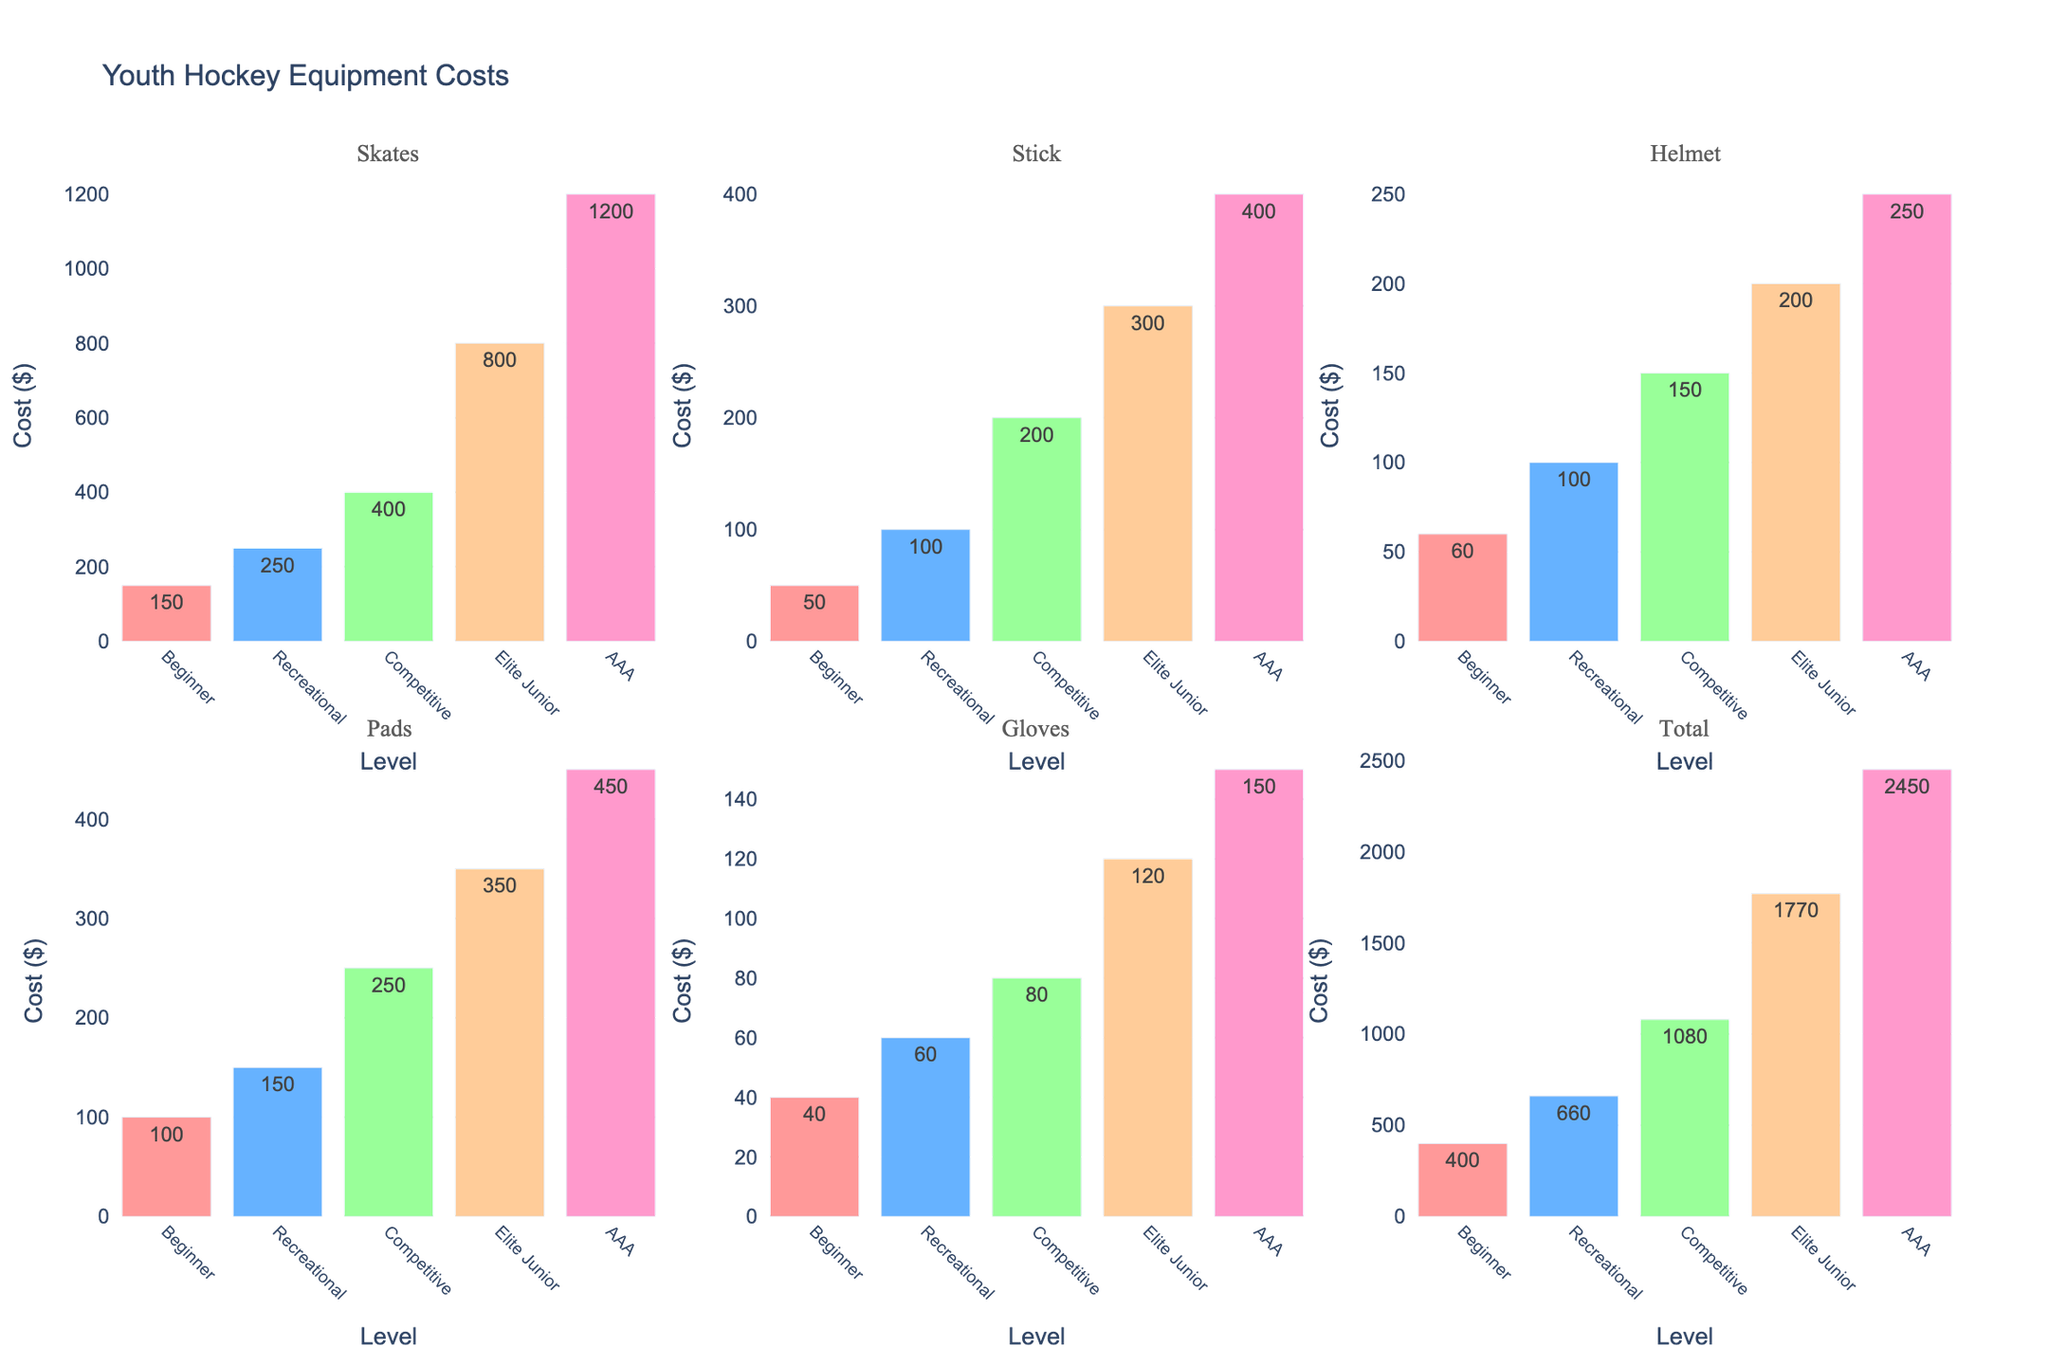What's the title of the figure? The title is usually displayed at the top of the figure. In this case, it would be the heading that provides an overview of what the figure represents.
Answer: Youth Hockey Equipment Costs What is the cost of skates for a Recreational level player? Locate the sub-figure titled "Skates," then find the bar corresponding to the "Recreational" level and read its height, which represents the cost.
Answer: $250 Which level has the highest total equipment cost? Look at the "Total" subplot and identify the tallest bar, which represents the highest total cost.
Answer: AAA What's the difference in the cost of helmets between Beginner and AAA levels? Locate the sub-figure titled "Helmet," get the cost values for Beginner and AAA, and subtract the Beginner cost from the AAA cost (250 - 60).
Answer: $190 What's the total cost for pads across all levels? Sum the values of the "Pads" subplot: 100 + 150 + 250 + 350 + 450.
Answer: $1,300 Compare the cost of sticks between Competitive and Elite Junior levels. Which one is more expensive and by how much? Locate the sub-figure titled "Stick," compare the values for Competitive and Elite Junior, then calculate the difference.
Answer: Elite Junior by $100 What color are the bars in the subplot for gloves? Observe the color of the bars in the subplot titled "Gloves." The color used for all bars is consistent across the subplots.
Answer: Pink, blue, green, orange, purple Which equipment type sees the largest increase in cost from Beginner to Recreational levels? Compare the increase between each equipment type from Beginner to Recreational by finding the difference.
Answer: Skates What's the average cost of gloves across all levels? Sum the values of the "Gloves" subplot (40 + 60 + 80 + 120 + 150), then divide by the number of levels (5).
Answer: $90 Are skates or sticks more expensive on average across all levels? Calculate the average cost for both Skates and Sticks across all levels, then compare the two averages.
Answer: Skates 